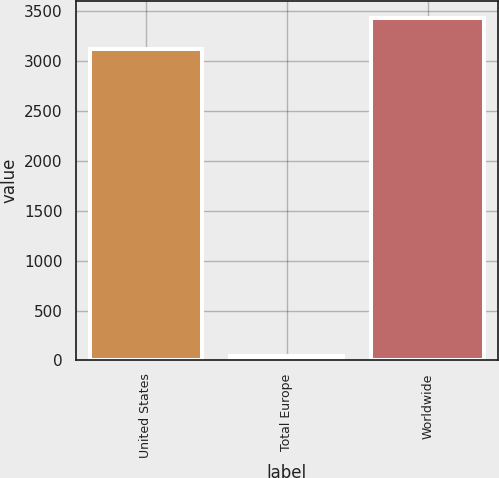Convert chart. <chart><loc_0><loc_0><loc_500><loc_500><bar_chart><fcel>United States<fcel>Total Europe<fcel>Worldwide<nl><fcel>3121<fcel>40<fcel>3434.5<nl></chart> 